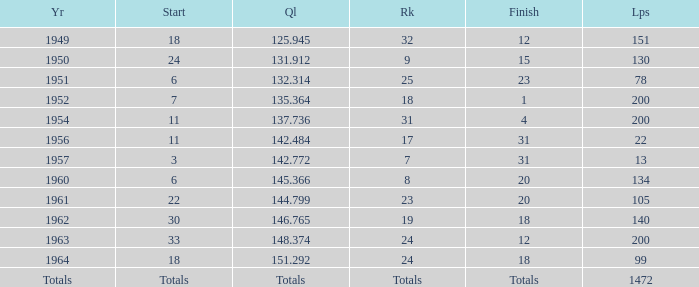Name the finish with Laps more than 200 Totals. 